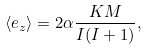Convert formula to latex. <formula><loc_0><loc_0><loc_500><loc_500>\langle e _ { z } \rangle = 2 \alpha \frac { K M } { I ( I + 1 ) } ,</formula> 